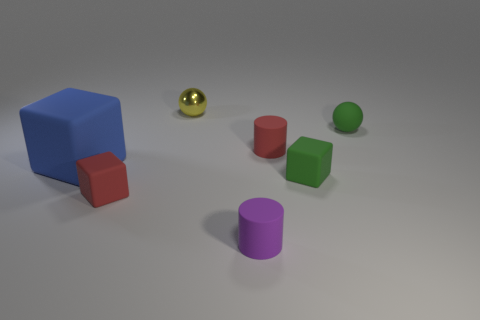Add 2 tiny blue metallic objects. How many objects exist? 9 Subtract all cylinders. How many objects are left? 5 Subtract 0 gray balls. How many objects are left? 7 Subtract all small metallic balls. Subtract all metal spheres. How many objects are left? 5 Add 6 blue matte blocks. How many blue matte blocks are left? 7 Add 5 blue rubber balls. How many blue rubber balls exist? 5 